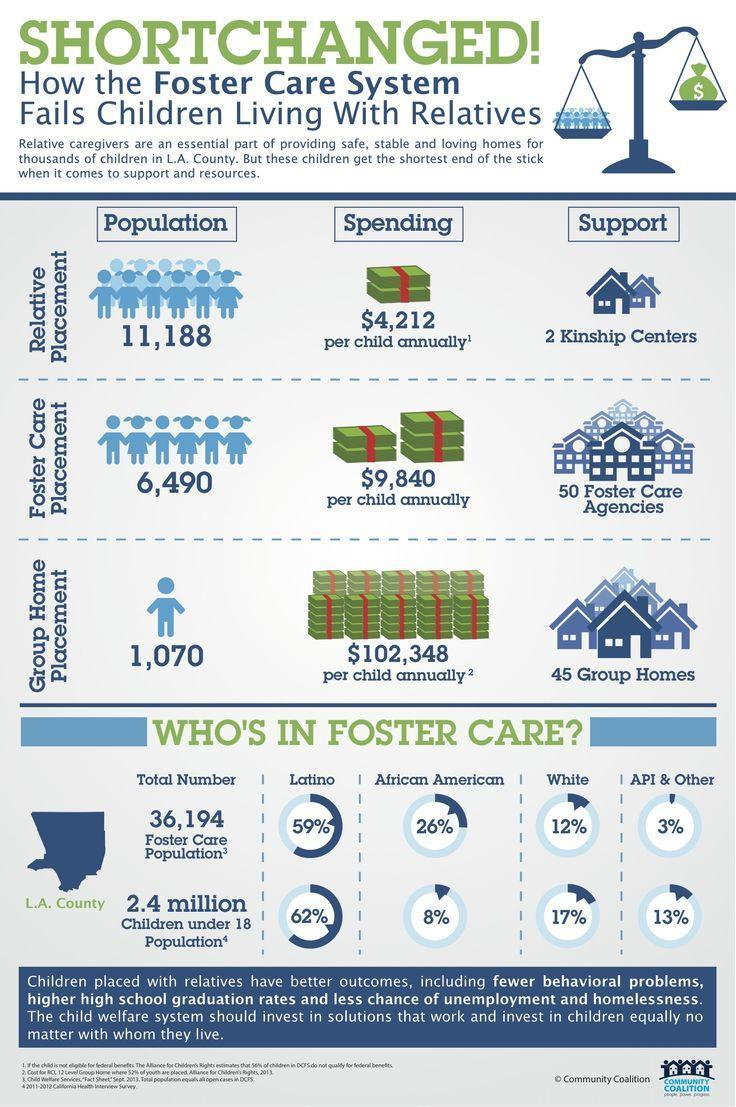Children belonging to which group makes second highest number in Foster Population?
Answer the question with a short phrase. White Which group of people has second highest percentage in Foster Care Population? African American How much more expensive is Foster care Placement when compared to Relative placement? 5,628 Which group of people has second least percentage in Foster Care Population? White Children belonging to which group makes third highest number in Foster Population? API & Other 